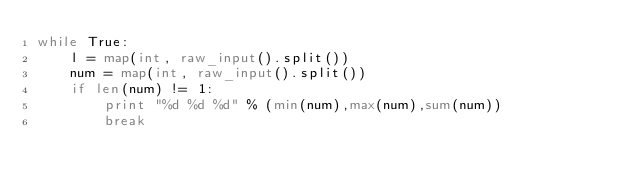Convert code to text. <code><loc_0><loc_0><loc_500><loc_500><_Python_>while True:
    l = map(int, raw_input().split())
    num = map(int, raw_input().split())
    if len(num) != 1:
        print "%d %d %d" % (min(num),max(num),sum(num))
        break</code> 